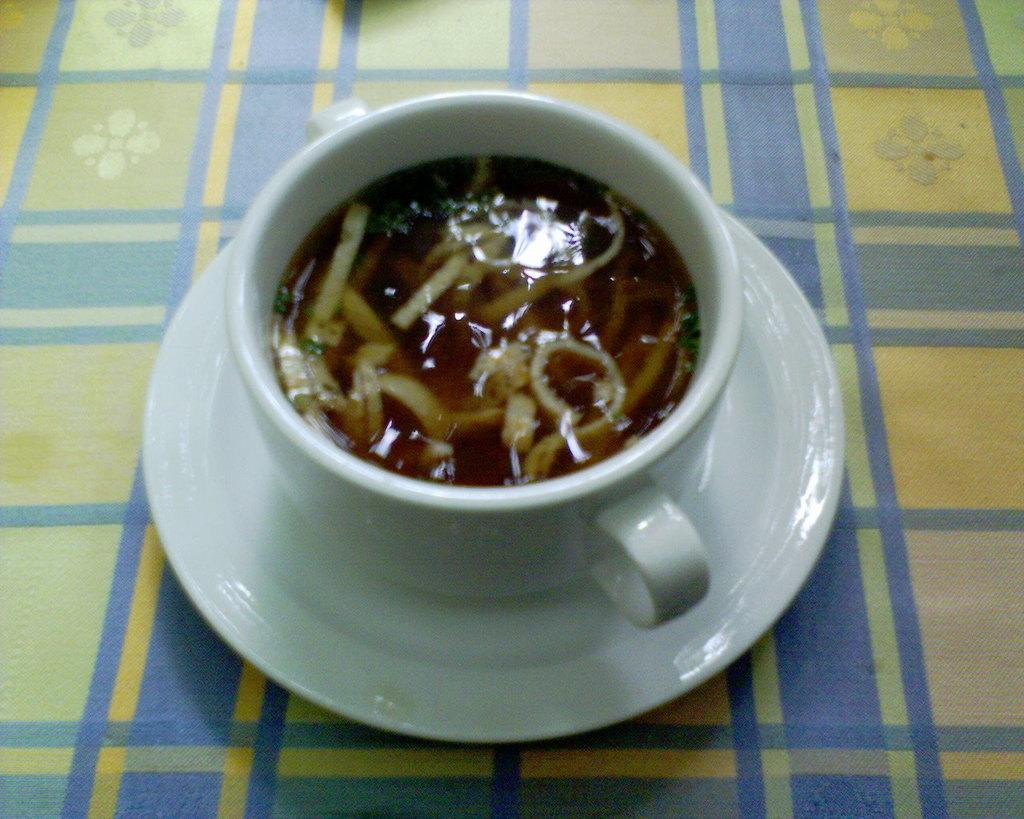What is in the cup that is visible in the image? There is a drink in the cup in the image. What is present in the image besides the cup with a drink? There is a saucer in the image. What is the saucer placed on? The saucer is on a cloth. Can you hear the tiger roaring in the image? There is no tiger or any sound present in the image. 